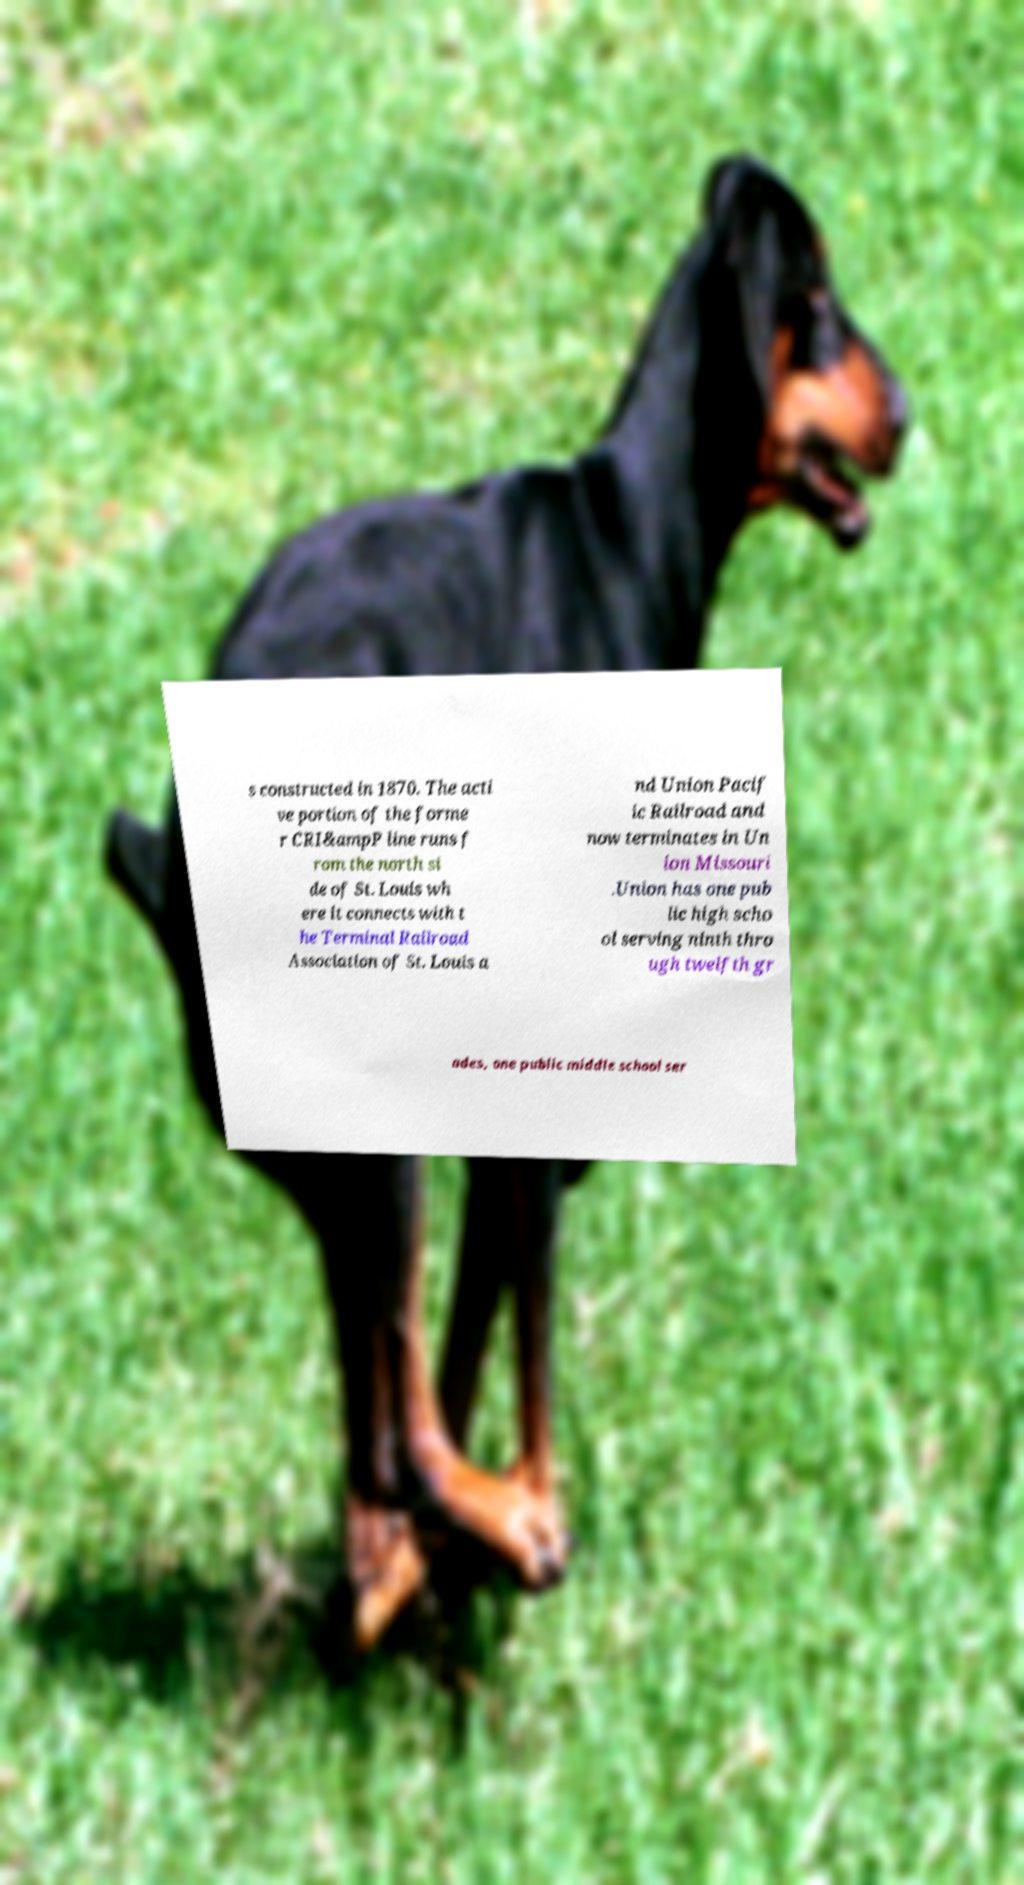There's text embedded in this image that I need extracted. Can you transcribe it verbatim? s constructed in 1870. The acti ve portion of the forme r CRI&ampP line runs f rom the north si de of St. Louis wh ere it connects with t he Terminal Railroad Association of St. Louis a nd Union Pacif ic Railroad and now terminates in Un ion Missouri .Union has one pub lic high scho ol serving ninth thro ugh twelfth gr ades, one public middle school ser 